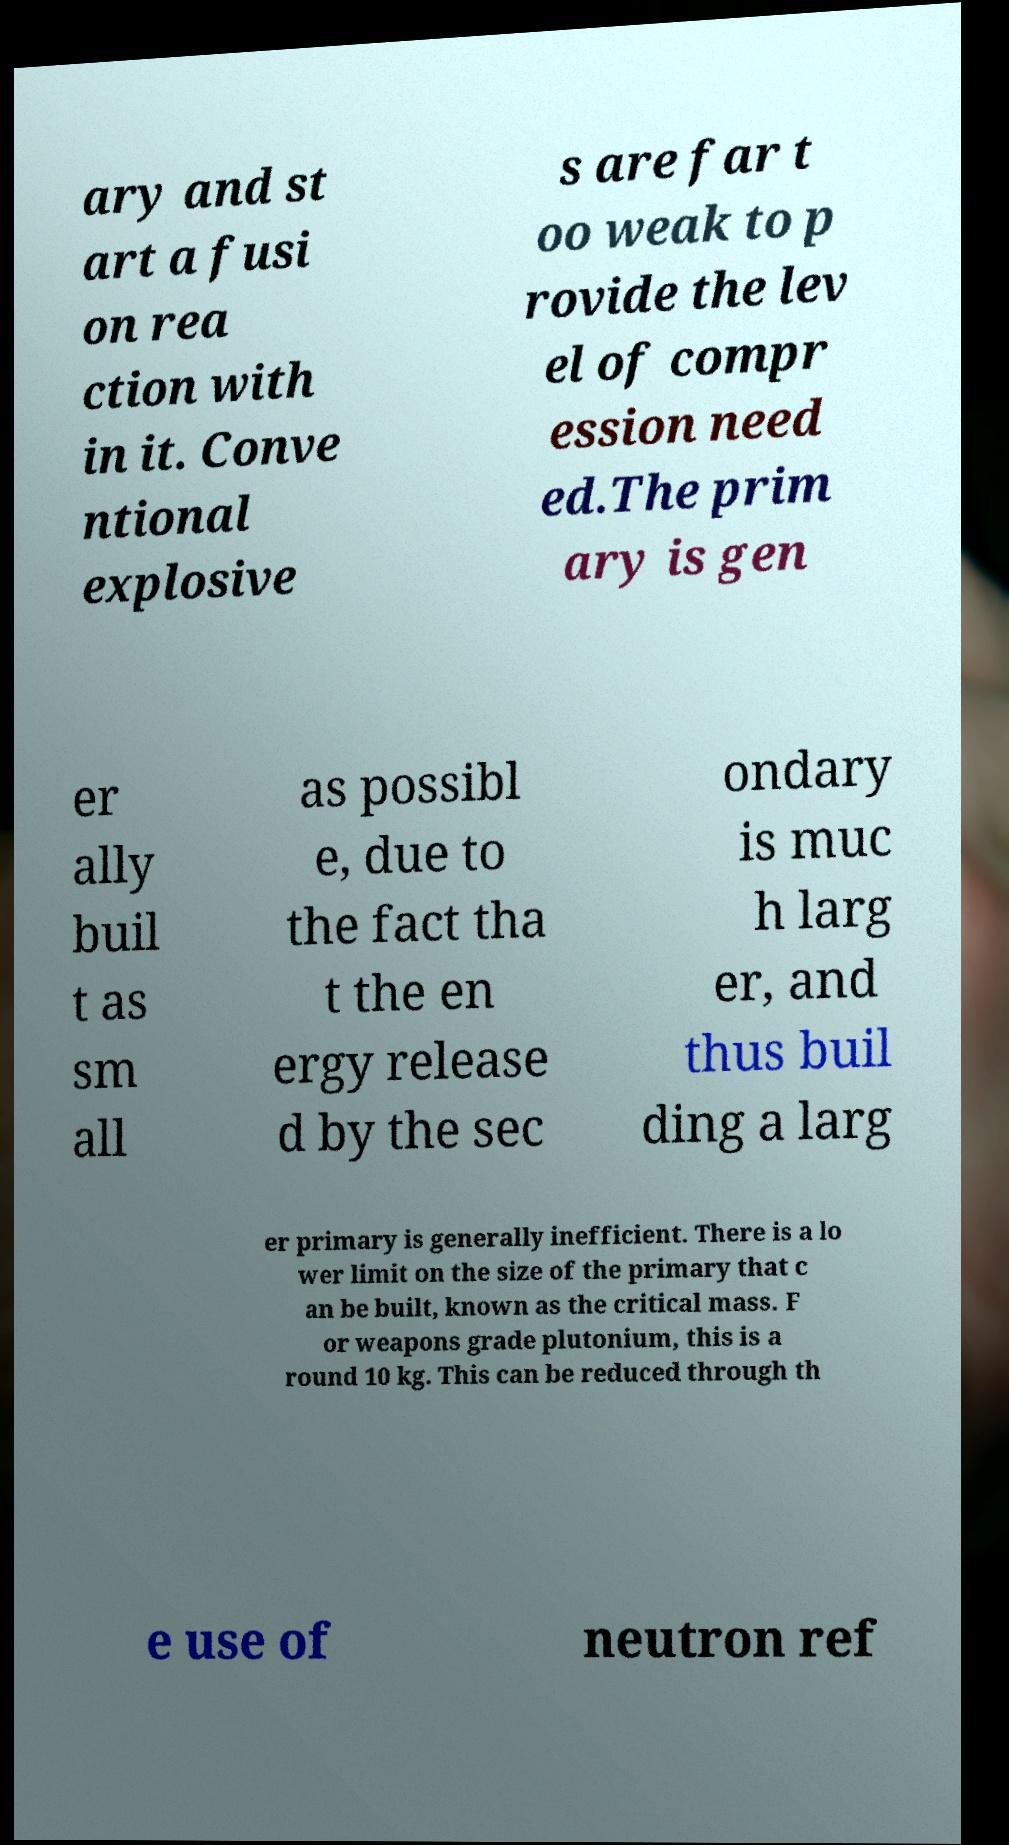I need the written content from this picture converted into text. Can you do that? ary and st art a fusi on rea ction with in it. Conve ntional explosive s are far t oo weak to p rovide the lev el of compr ession need ed.The prim ary is gen er ally buil t as sm all as possibl e, due to the fact tha t the en ergy release d by the sec ondary is muc h larg er, and thus buil ding a larg er primary is generally inefficient. There is a lo wer limit on the size of the primary that c an be built, known as the critical mass. F or weapons grade plutonium, this is a round 10 kg. This can be reduced through th e use of neutron ref 